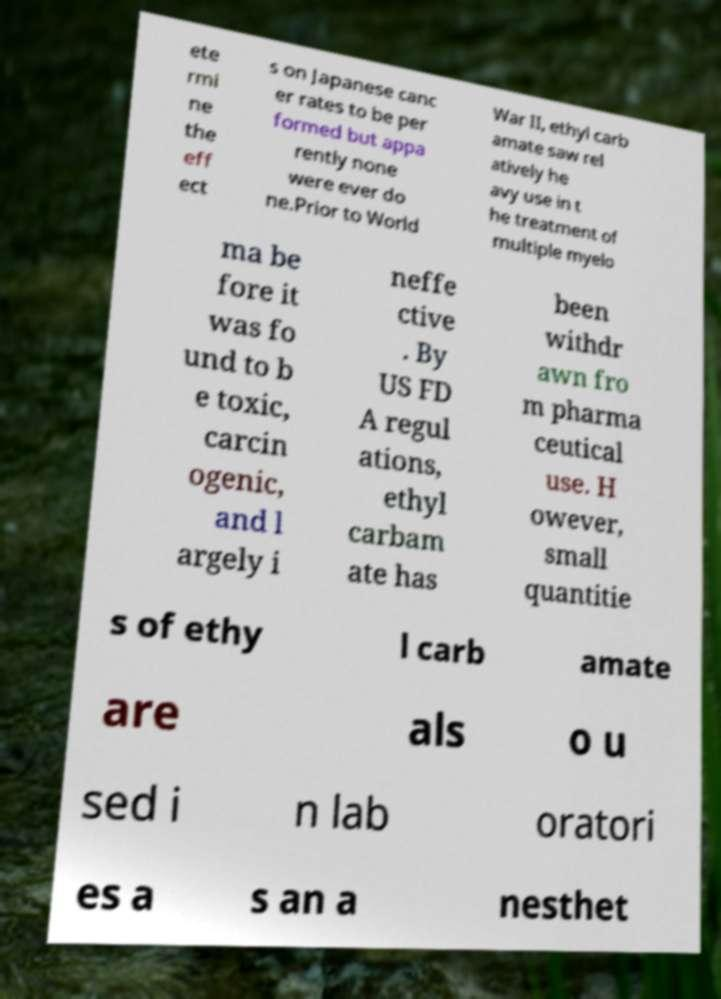Can you accurately transcribe the text from the provided image for me? ete rmi ne the eff ect s on Japanese canc er rates to be per formed but appa rently none were ever do ne.Prior to World War II, ethyl carb amate saw rel atively he avy use in t he treatment of multiple myelo ma be fore it was fo und to b e toxic, carcin ogenic, and l argely i neffe ctive . By US FD A regul ations, ethyl carbam ate has been withdr awn fro m pharma ceutical use. H owever, small quantitie s of ethy l carb amate are als o u sed i n lab oratori es a s an a nesthet 